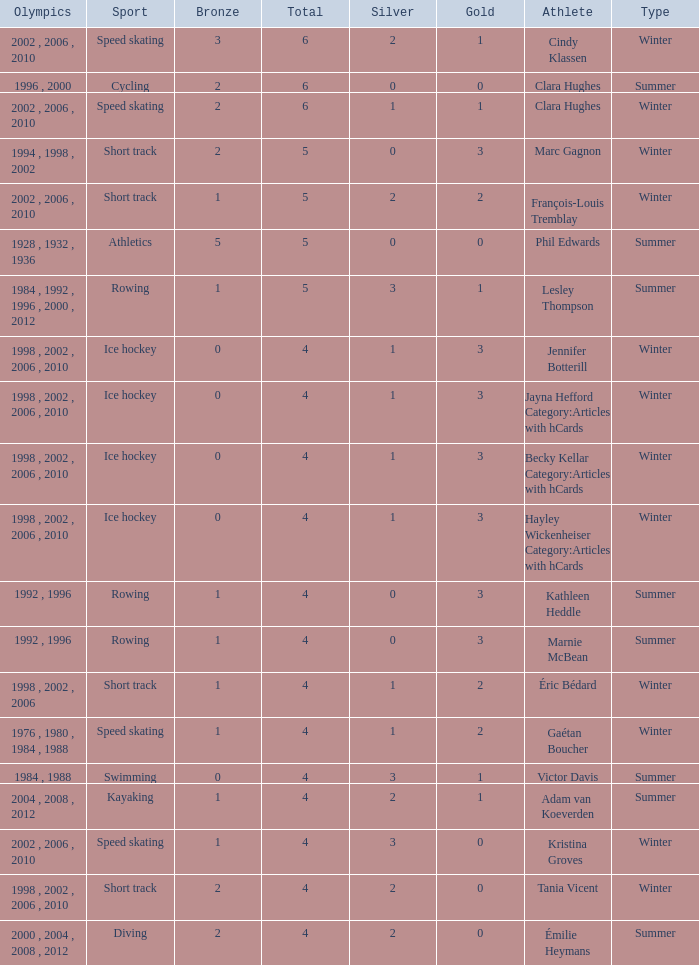What is the average gold of the winter athlete with 1 bronze, less than 3 silver, and less than 4 total medals? None. 